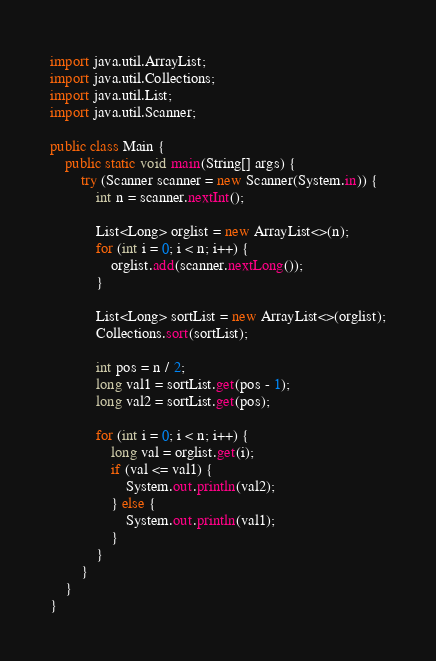<code> <loc_0><loc_0><loc_500><loc_500><_Java_>import java.util.ArrayList;
import java.util.Collections;
import java.util.List;
import java.util.Scanner;

public class Main {
	public static void main(String[] args) {
		try (Scanner scanner = new Scanner(System.in)) {
			int n = scanner.nextInt();

			List<Long> orglist = new ArrayList<>(n);
			for (int i = 0; i < n; i++) {
				orglist.add(scanner.nextLong());
			}

			List<Long> sortList = new ArrayList<>(orglist);
			Collections.sort(sortList);

			int pos = n / 2;
			long val1 = sortList.get(pos - 1);
			long val2 = sortList.get(pos);

			for (int i = 0; i < n; i++) {
				long val = orglist.get(i);
				if (val <= val1) {
					System.out.println(val2);
				} else {
					System.out.println(val1);
				}
			}
		}
	}
}
</code> 